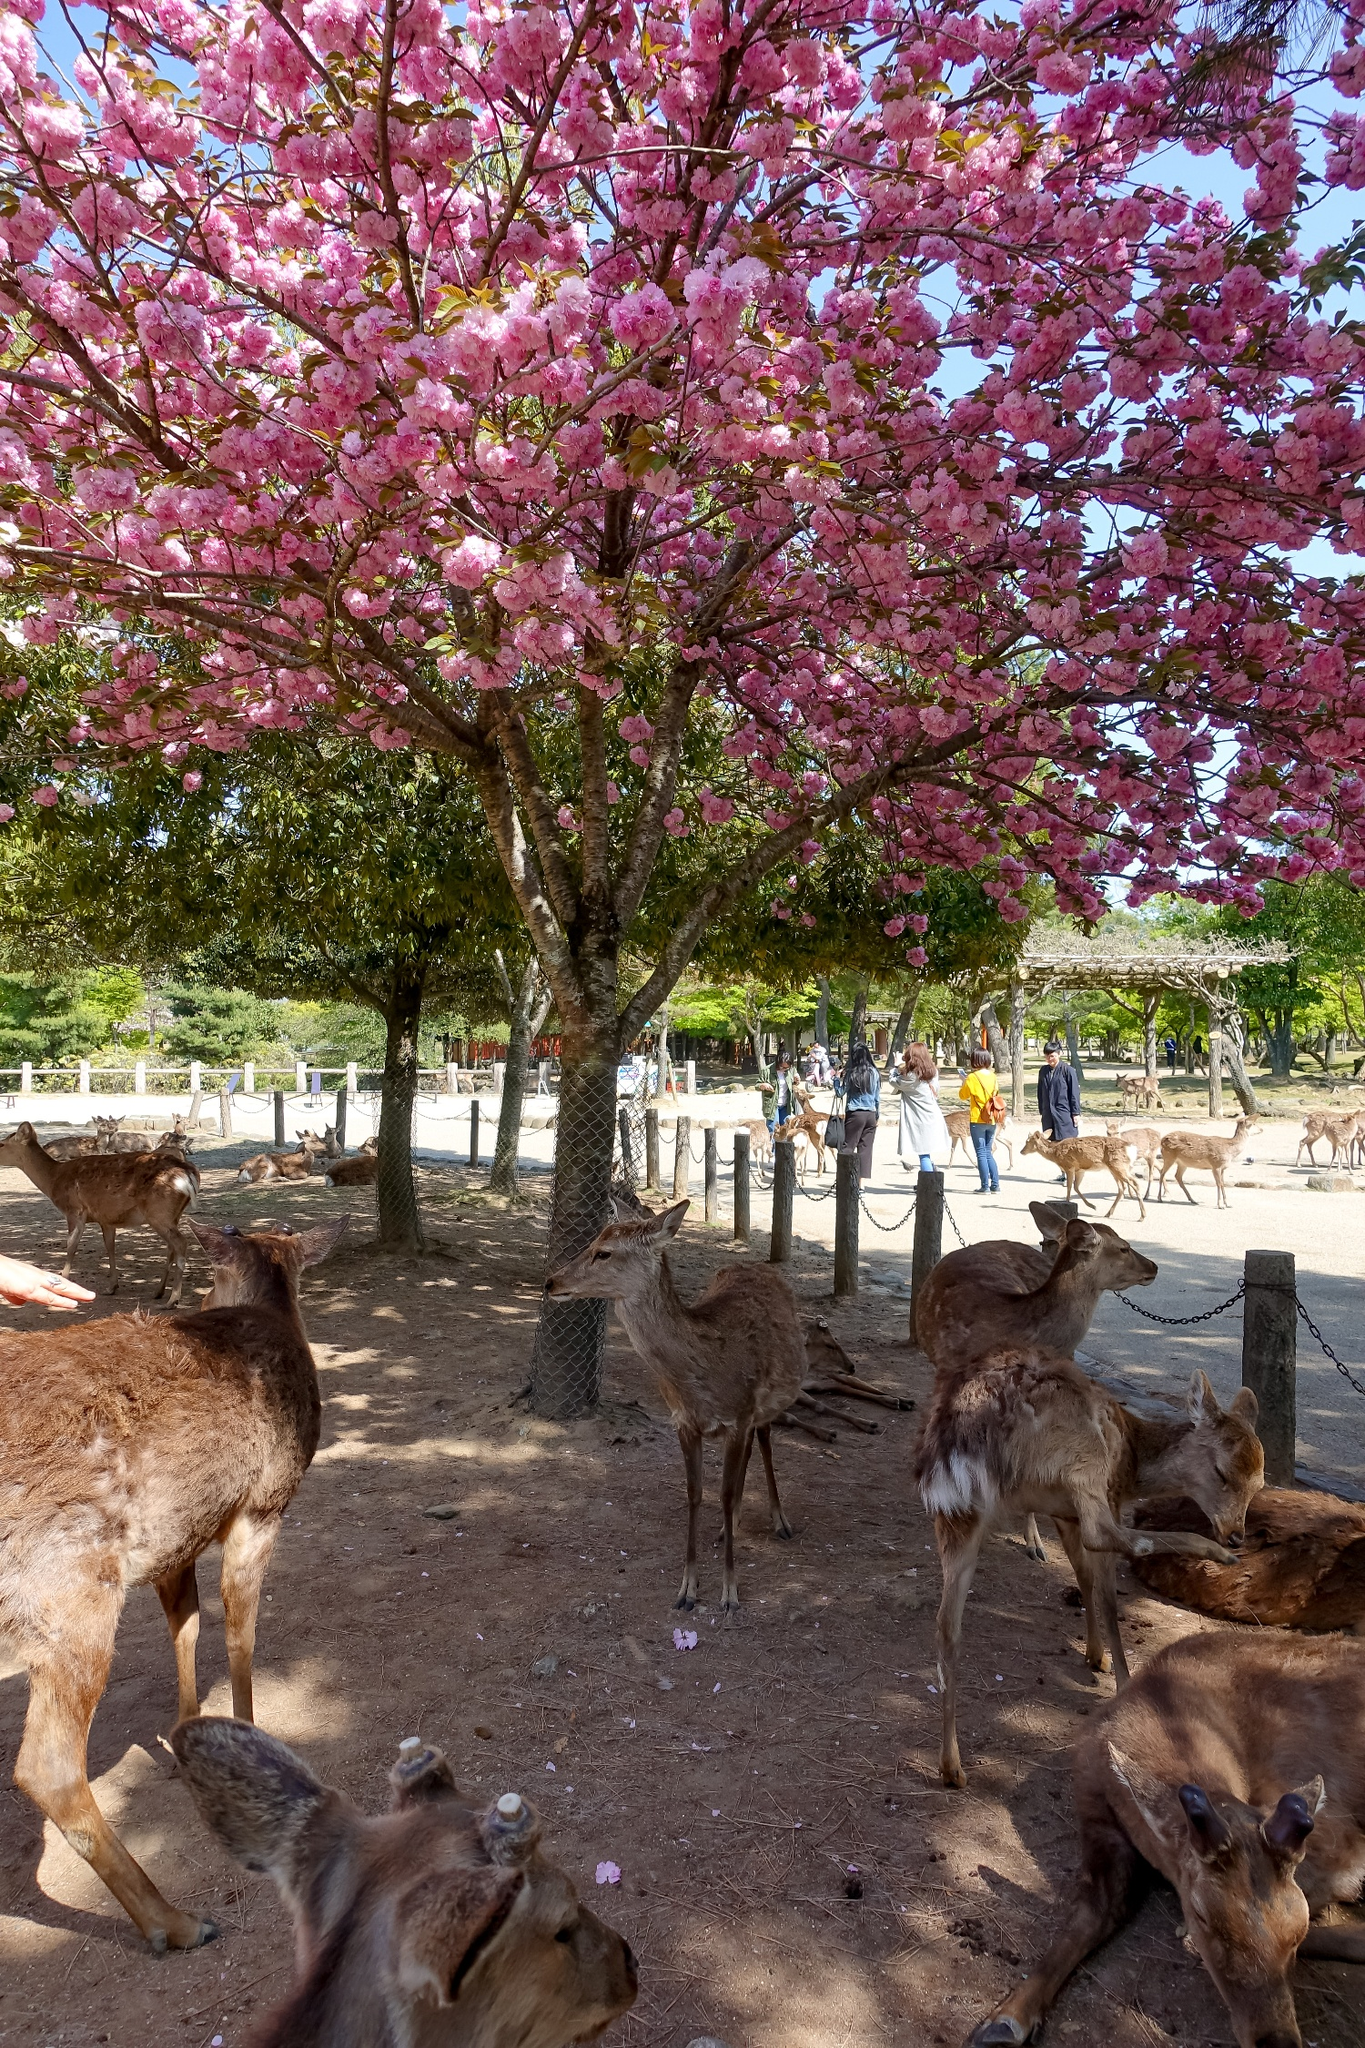Describe the following image. The image portrays a tranquil park scene dominated by a magnificent cherry blossom tree in full bloom. The tree is adorned with vibrant pink flowers, standing gracefully above a dirt pathway. Beneath this tree, a group of at least six brown deer are scattered around; some are lying down while others are standing, exuding a peaceful atmosphere. In the background, a few people can be seen walking, adding a lively but unobtrusive human presence to the scene. The overall setting reflects a harmonious coexistence between wildlife and visitors in a serene park environment. 